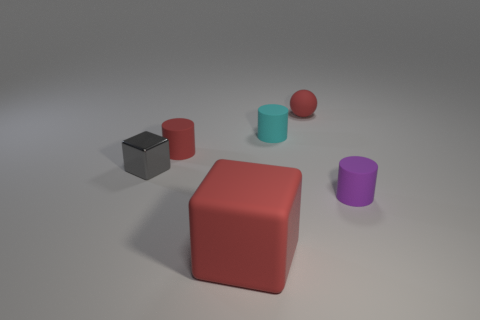Add 4 shiny cubes. How many objects exist? 10 Subtract all blue cylinders. Subtract all green cubes. How many cylinders are left? 3 Subtract all blocks. How many objects are left? 4 Add 4 small purple cylinders. How many small purple cylinders exist? 5 Subtract 1 gray blocks. How many objects are left? 5 Subtract all large red things. Subtract all small red matte cylinders. How many objects are left? 4 Add 3 tiny gray blocks. How many tiny gray blocks are left? 4 